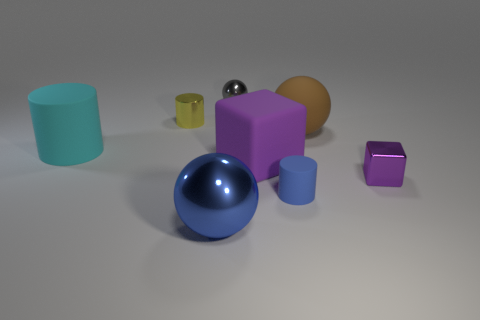Add 2 large blue spheres. How many objects exist? 10 Subtract all cylinders. How many objects are left? 5 Subtract all cyan cubes. Subtract all small blue matte cylinders. How many objects are left? 7 Add 1 large purple rubber blocks. How many large purple rubber blocks are left? 2 Add 7 big brown matte spheres. How many big brown matte spheres exist? 8 Subtract 0 cyan cubes. How many objects are left? 8 